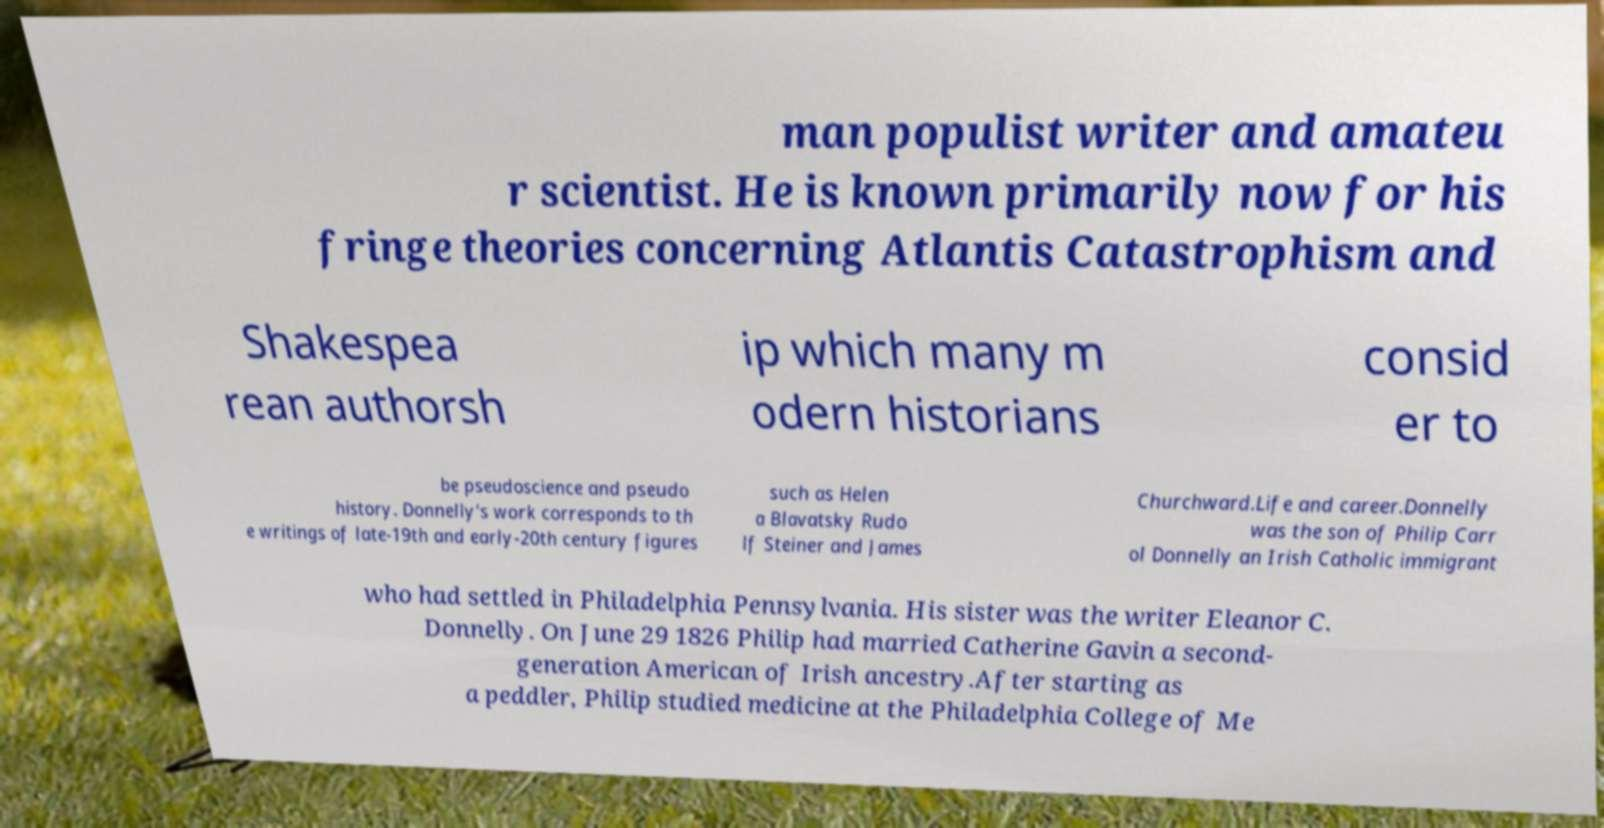Could you assist in decoding the text presented in this image and type it out clearly? man populist writer and amateu r scientist. He is known primarily now for his fringe theories concerning Atlantis Catastrophism and Shakespea rean authorsh ip which many m odern historians consid er to be pseudoscience and pseudo history. Donnelly's work corresponds to th e writings of late-19th and early-20th century figures such as Helen a Blavatsky Rudo lf Steiner and James Churchward.Life and career.Donnelly was the son of Philip Carr ol Donnelly an Irish Catholic immigrant who had settled in Philadelphia Pennsylvania. His sister was the writer Eleanor C. Donnelly. On June 29 1826 Philip had married Catherine Gavin a second- generation American of Irish ancestry.After starting as a peddler, Philip studied medicine at the Philadelphia College of Me 